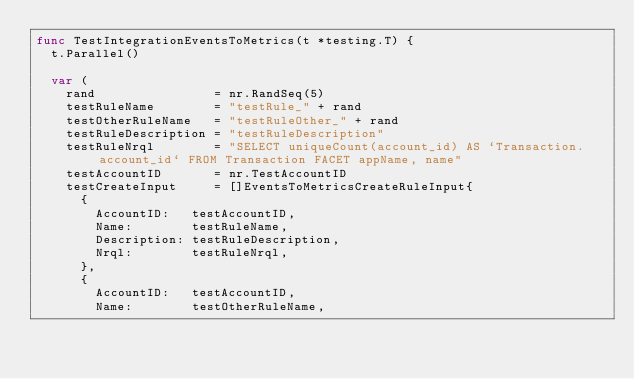<code> <loc_0><loc_0><loc_500><loc_500><_Go_>func TestIntegrationEventsToMetrics(t *testing.T) {
	t.Parallel()

	var (
		rand                = nr.RandSeq(5)
		testRuleName        = "testRule_" + rand
		testOtherRuleName   = "testRuleOther_" + rand
		testRuleDescription = "testRuleDescription"
		testRuleNrql        = "SELECT uniqueCount(account_id) AS `Transaction.account_id` FROM Transaction FACET appName, name"
		testAccountID       = nr.TestAccountID
		testCreateInput     = []EventsToMetricsCreateRuleInput{
			{
				AccountID:   testAccountID,
				Name:        testRuleName,
				Description: testRuleDescription,
				Nrql:        testRuleNrql,
			},
			{
				AccountID:   testAccountID,
				Name:        testOtherRuleName,</code> 